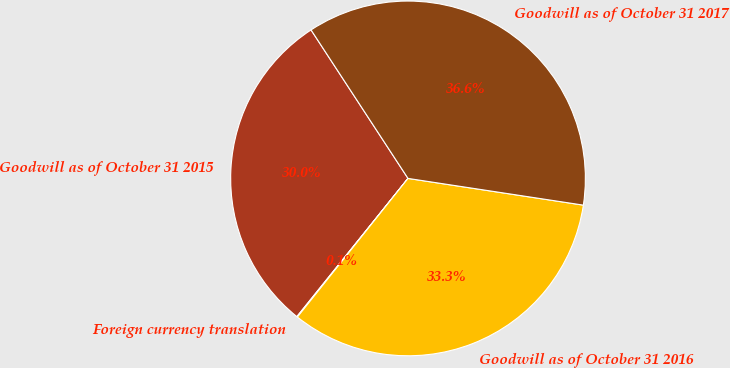Convert chart. <chart><loc_0><loc_0><loc_500><loc_500><pie_chart><fcel>Goodwill as of October 31 2015<fcel>Foreign currency translation<fcel>Goodwill as of October 31 2016<fcel>Goodwill as of October 31 2017<nl><fcel>30.01%<fcel>0.06%<fcel>33.31%<fcel>36.61%<nl></chart> 